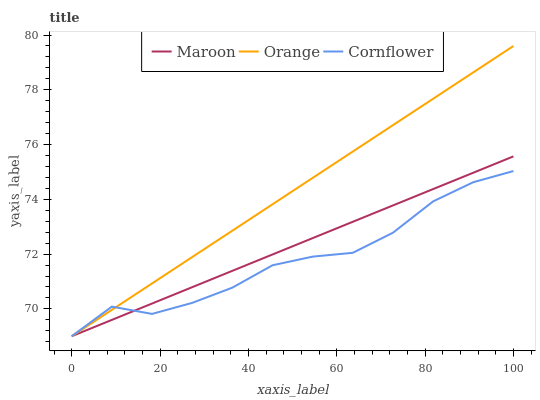Does Cornflower have the minimum area under the curve?
Answer yes or no. Yes. Does Orange have the maximum area under the curve?
Answer yes or no. Yes. Does Maroon have the minimum area under the curve?
Answer yes or no. No. Does Maroon have the maximum area under the curve?
Answer yes or no. No. Is Maroon the smoothest?
Answer yes or no. Yes. Is Cornflower the roughest?
Answer yes or no. Yes. Is Cornflower the smoothest?
Answer yes or no. No. Is Maroon the roughest?
Answer yes or no. No. Does Orange have the lowest value?
Answer yes or no. Yes. Does Orange have the highest value?
Answer yes or no. Yes. Does Maroon have the highest value?
Answer yes or no. No. Does Maroon intersect Cornflower?
Answer yes or no. Yes. Is Maroon less than Cornflower?
Answer yes or no. No. Is Maroon greater than Cornflower?
Answer yes or no. No. 